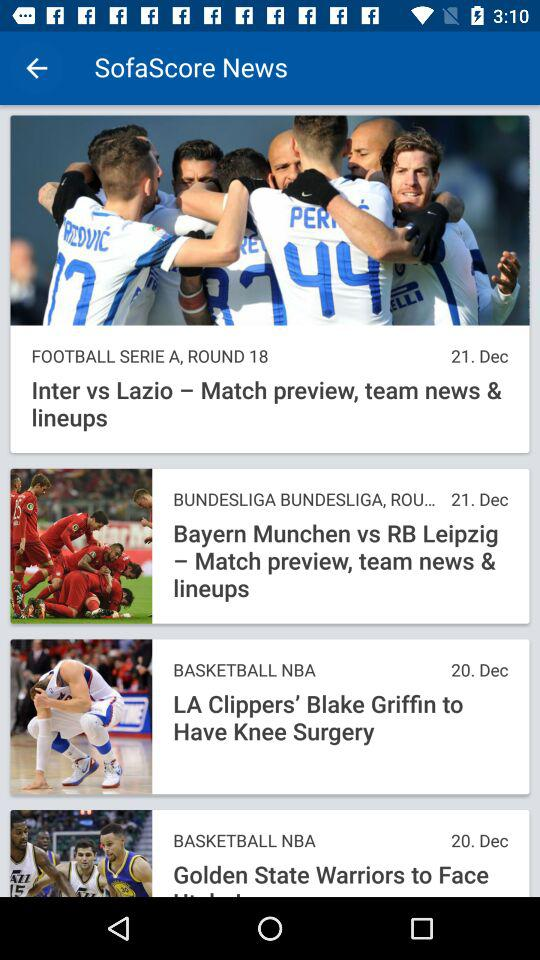On what date was the news about the basketball NBA posted? The news about the basketball NBA was posted on December 20. 